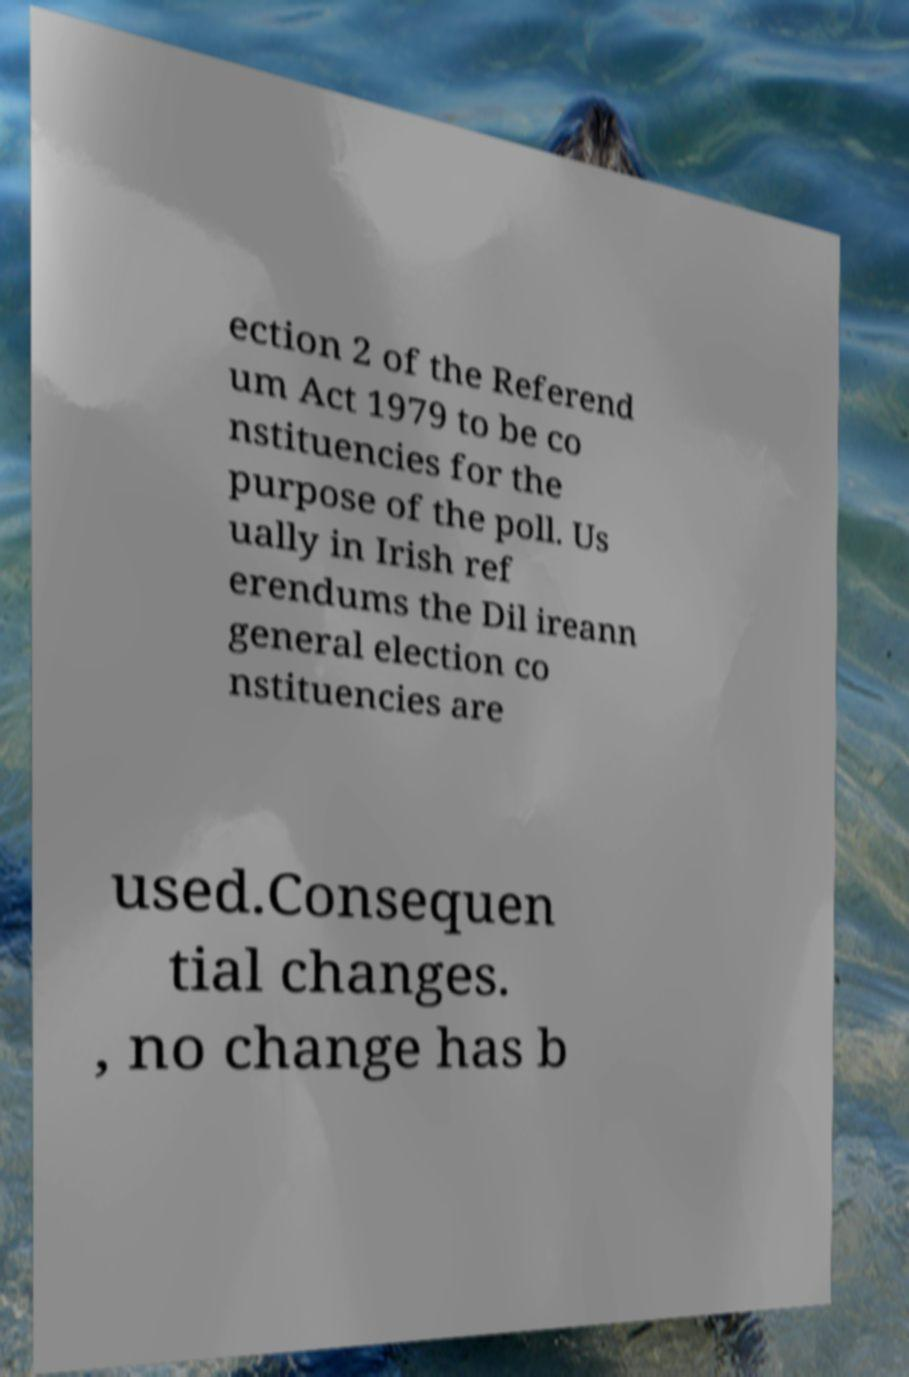What messages or text are displayed in this image? I need them in a readable, typed format. ection 2 of the Referend um Act 1979 to be co nstituencies for the purpose of the poll. Us ually in Irish ref erendums the Dil ireann general election co nstituencies are used.Consequen tial changes. , no change has b 